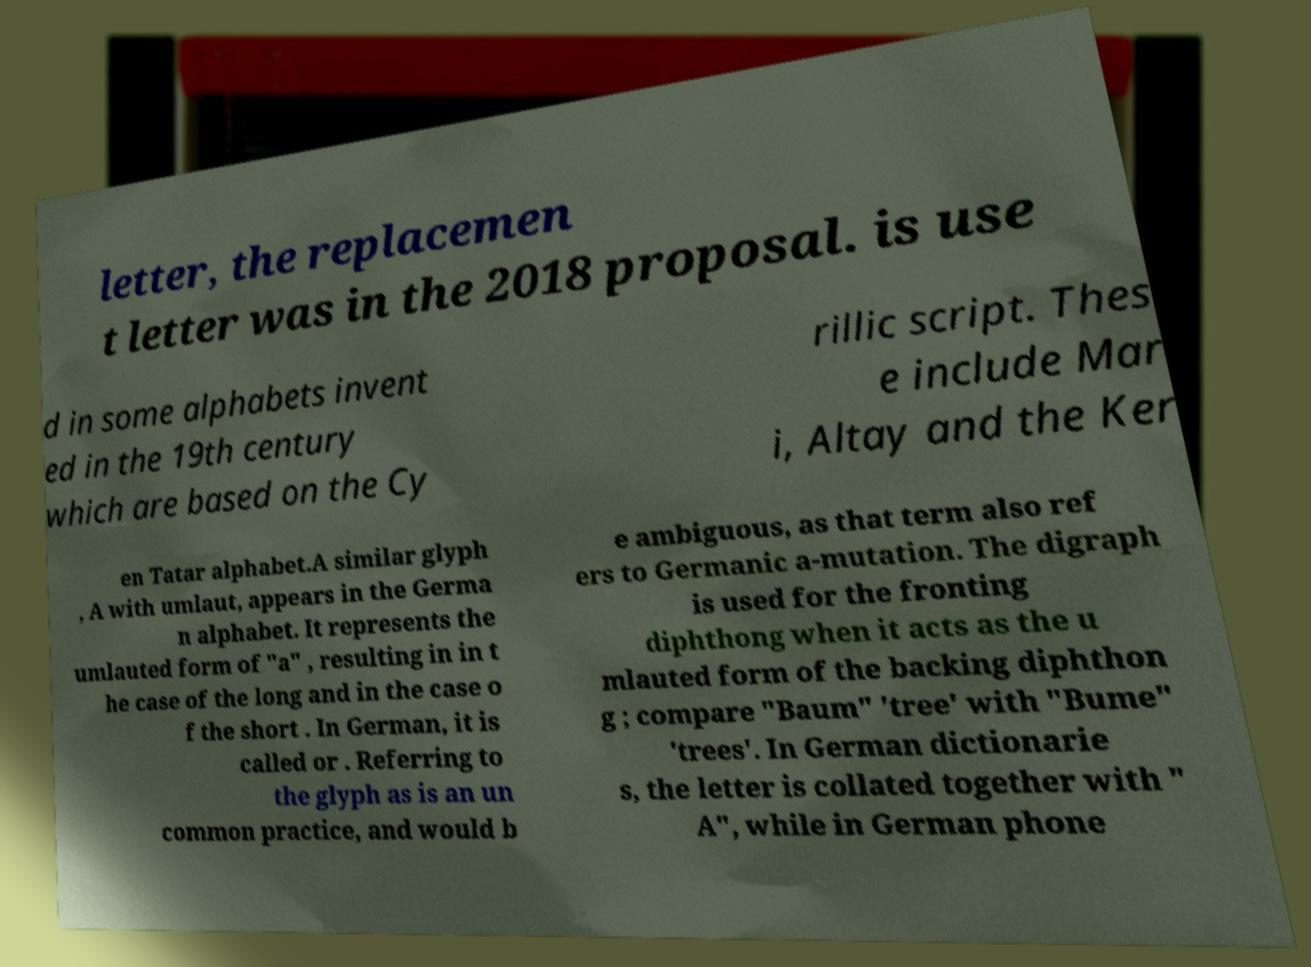Could you extract and type out the text from this image? letter, the replacemen t letter was in the 2018 proposal. is use d in some alphabets invent ed in the 19th century which are based on the Cy rillic script. Thes e include Mar i, Altay and the Ker en Tatar alphabet.A similar glyph , A with umlaut, appears in the Germa n alphabet. It represents the umlauted form of "a" , resulting in in t he case of the long and in the case o f the short . In German, it is called or . Referring to the glyph as is an un common practice, and would b e ambiguous, as that term also ref ers to Germanic a-mutation. The digraph is used for the fronting diphthong when it acts as the u mlauted form of the backing diphthon g ; compare "Baum" 'tree' with "Bume" 'trees'. In German dictionarie s, the letter is collated together with " A", while in German phone 